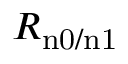Convert formula to latex. <formula><loc_0><loc_0><loc_500><loc_500>R _ { n 0 / n 1 }</formula> 